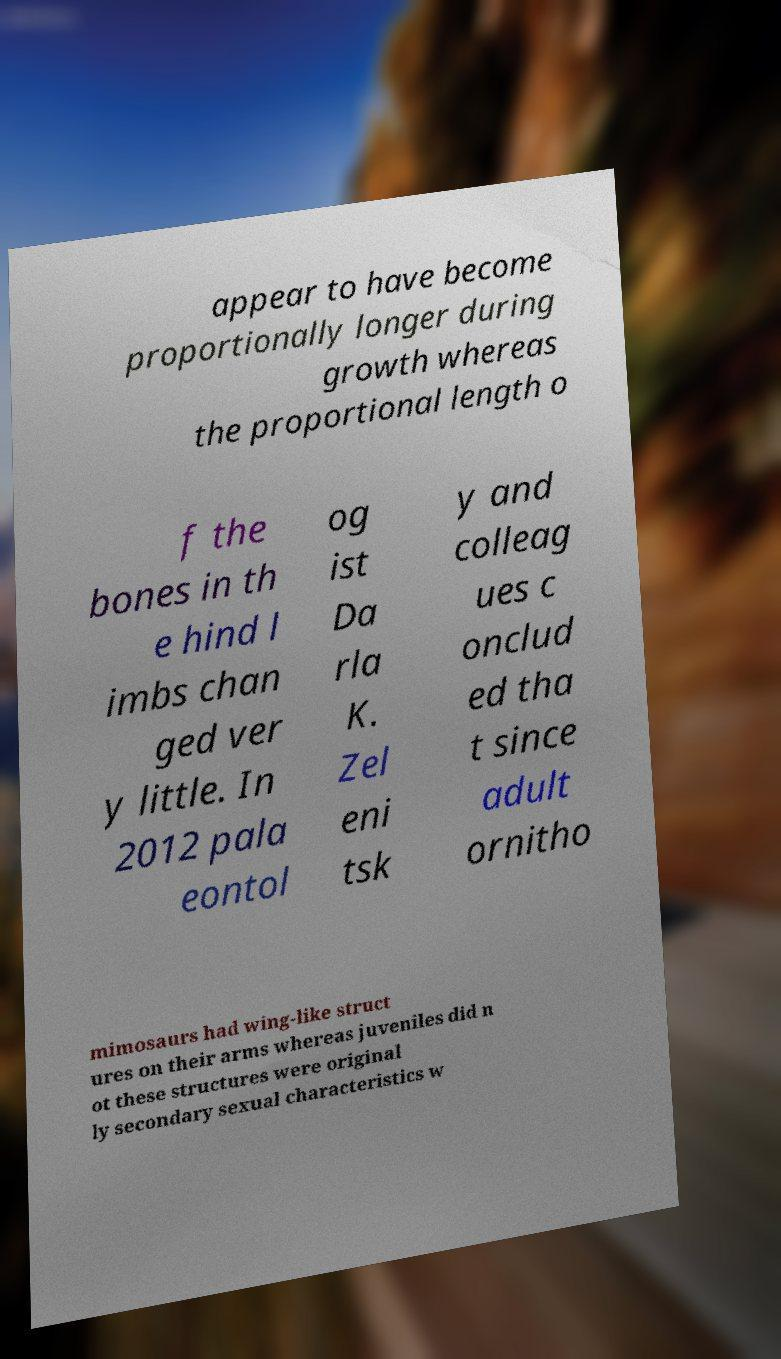Can you accurately transcribe the text from the provided image for me? appear to have become proportionally longer during growth whereas the proportional length o f the bones in th e hind l imbs chan ged ver y little. In 2012 pala eontol og ist Da rla K. Zel eni tsk y and colleag ues c onclud ed tha t since adult ornitho mimosaurs had wing-like struct ures on their arms whereas juveniles did n ot these structures were original ly secondary sexual characteristics w 